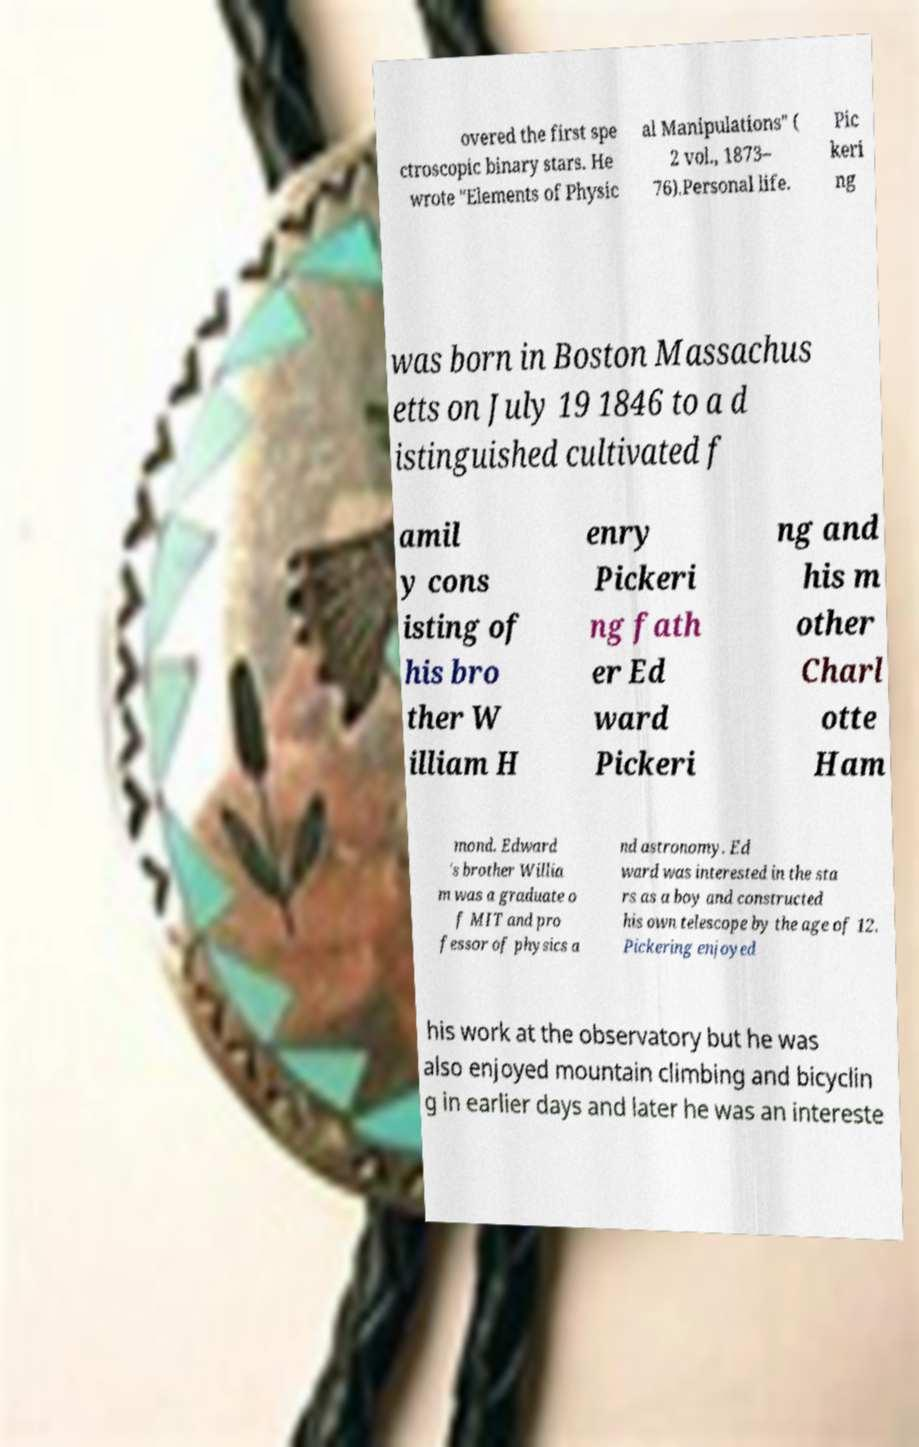Can you accurately transcribe the text from the provided image for me? overed the first spe ctroscopic binary stars. He wrote "Elements of Physic al Manipulations" ( 2 vol., 1873– 76).Personal life. Pic keri ng was born in Boston Massachus etts on July 19 1846 to a d istinguished cultivated f amil y cons isting of his bro ther W illiam H enry Pickeri ng fath er Ed ward Pickeri ng and his m other Charl otte Ham mond. Edward 's brother Willia m was a graduate o f MIT and pro fessor of physics a nd astronomy. Ed ward was interested in the sta rs as a boy and constructed his own telescope by the age of 12. Pickering enjoyed his work at the observatory but he was also enjoyed mountain climbing and bicyclin g in earlier days and later he was an intereste 